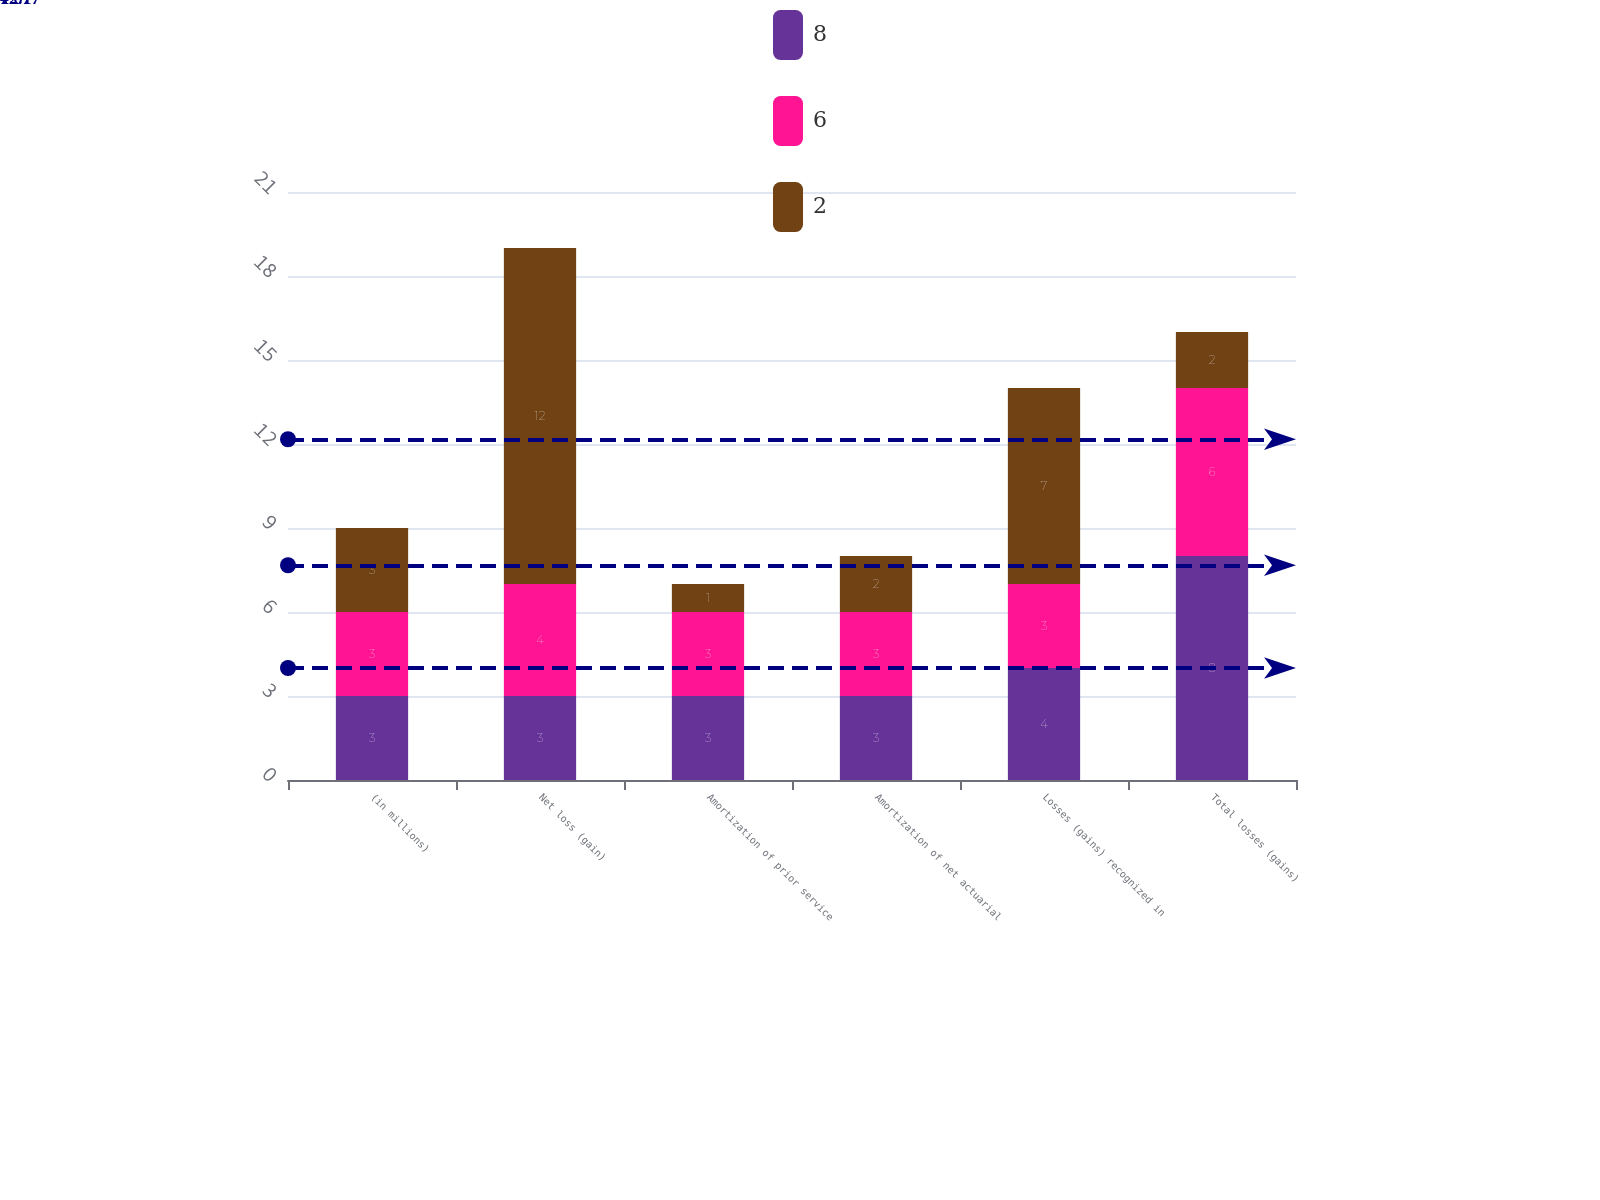<chart> <loc_0><loc_0><loc_500><loc_500><stacked_bar_chart><ecel><fcel>(in millions)<fcel>Net loss (gain)<fcel>Amortization of prior service<fcel>Amortization of net actuarial<fcel>Losses (gains) recognized in<fcel>Total losses (gains)<nl><fcel>8<fcel>3<fcel>3<fcel>3<fcel>3<fcel>4<fcel>8<nl><fcel>6<fcel>3<fcel>4<fcel>3<fcel>3<fcel>3<fcel>6<nl><fcel>2<fcel>3<fcel>12<fcel>1<fcel>2<fcel>7<fcel>2<nl></chart> 